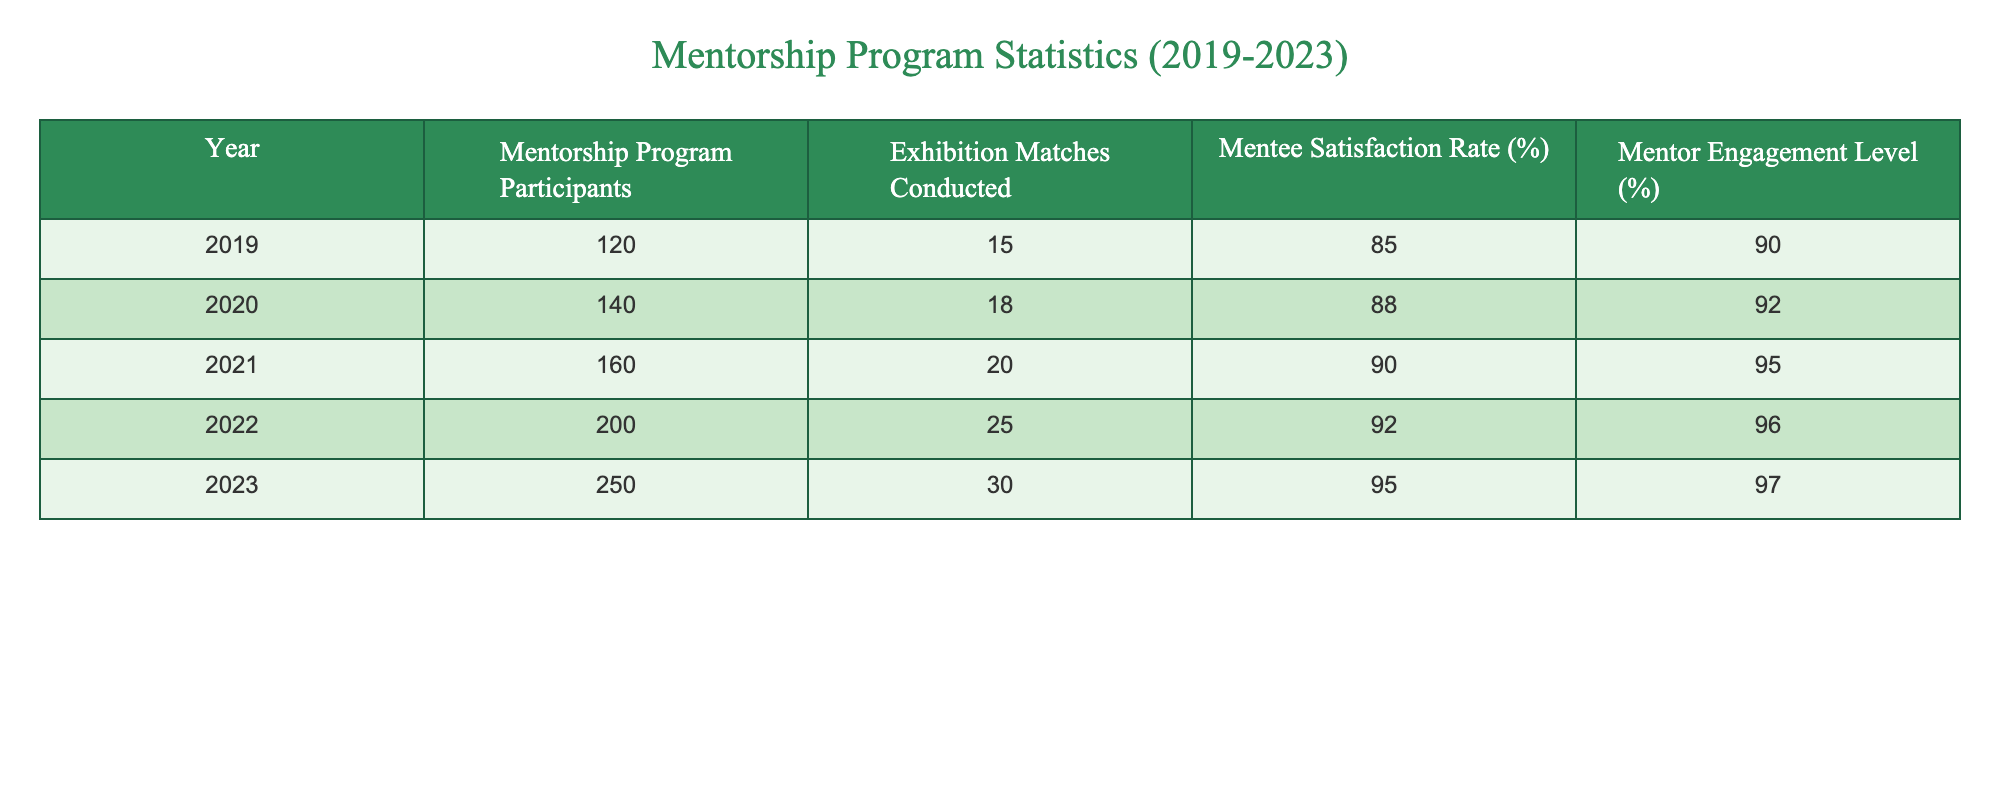What was the highest number of mentorship program participants in a single year? The table shows the number of mentorship program participants for each year from 2019 to 2023. By checking each row, we see that 2023 had the highest number at 250 participants.
Answer: 250 What was the mentee satisfaction rate in 2021? The table lists the mentee satisfaction rate for each year. In 2021, the mentee satisfaction rate is given as 90%.
Answer: 90% Is the number of exhibition matches conducted in 2019 greater than in 2020? The table shows that in 2019, there were 15 matches, while in 2020 there were 18 matches. Since 15 is less than 18, the statement is false.
Answer: No What was the average mentee satisfaction rate over the five years? To find the average, we add the mentee satisfaction rates from each year (85 + 88 + 90 + 92 + 95) = 450. We then divide by the number of years (5) to get an average of 450/5 = 90%.
Answer: 90 How much did the mentor engagement level increase from 2019 to 2023? In 2019, the mentor engagement level was 90%, and in 2023 it is 97%. To find the increase, we subtract the earlier value from the later value: 97 - 90 = 7%.
Answer: 7% Did the number of mentorship program participants increase every year? By examining the table, we see that the number of participants grew from 120 in 2019 to 250 in 2023 without any declines in between. Thus, the answer is yes.
Answer: Yes What was the difference in exhibition matches conducted between 2022 and 2023? The number of matches conducted in 2022 was 25 and in 2023 it was 30. To find the difference, we subtract the two: 30 - 25 = 5 matches.
Answer: 5 What is the total number of exhibition matches conducted from 2019 to 2023? To find the total, we add the number of matches for each year: 15 + 18 + 20 + 25 + 30 = 108 matches conducted over the five years.
Answer: 108 What was the mentor engagement level in 2020 and was it higher than in 2019? The mentor engagement level was 92% in 2020 and 90% in 2019. Comparing these values, 92% is higher than 90%.
Answer: Yes 